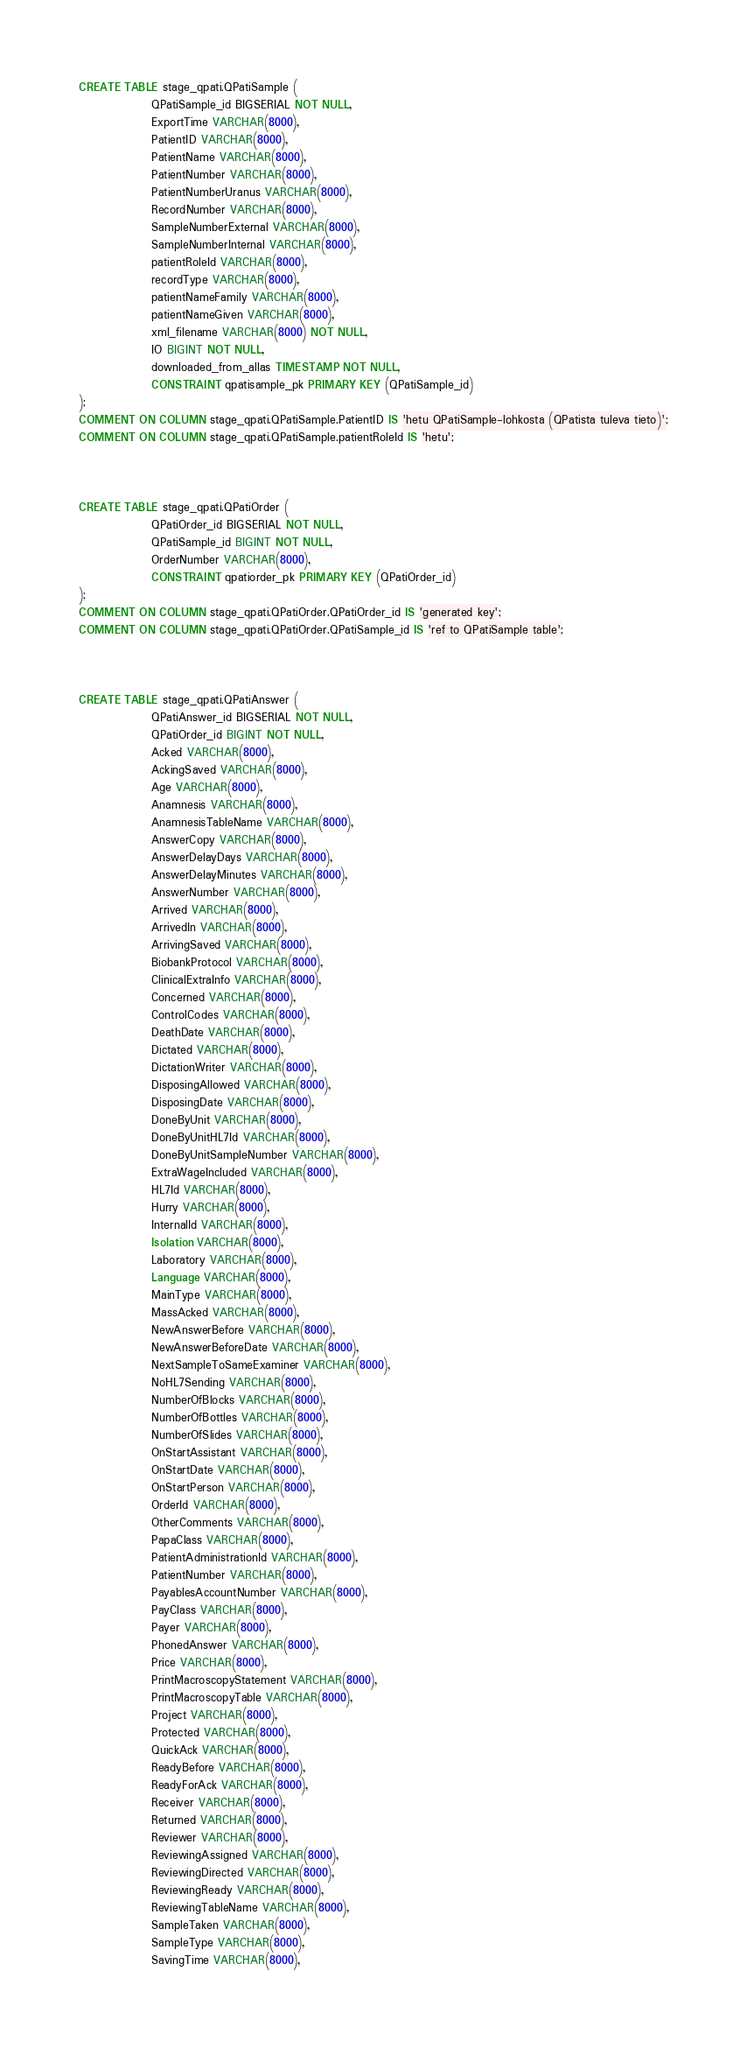Convert code to text. <code><loc_0><loc_0><loc_500><loc_500><_SQL_>
CREATE TABLE stage_qpati.QPatiSample (
                QPatiSample_id BIGSERIAL NOT NULL,
                ExportTime VARCHAR(8000),
                PatientID VARCHAR(8000),
                PatientName VARCHAR(8000),
                PatientNumber VARCHAR(8000),
                PatientNumberUranus VARCHAR(8000),
                RecordNumber VARCHAR(8000),
                SampleNumberExternal VARCHAR(8000),
                SampleNumberInternal VARCHAR(8000),
                patientRoleId VARCHAR(8000),
                recordType VARCHAR(8000),
                patientNameFamily VARCHAR(8000),
                patientNameGiven VARCHAR(8000),
                xml_filename VARCHAR(8000) NOT NULL,
                IO BIGINT NOT NULL,
                downloaded_from_allas TIMESTAMP NOT NULL,
                CONSTRAINT qpatisample_pk PRIMARY KEY (QPatiSample_id)
);
COMMENT ON COLUMN stage_qpati.QPatiSample.PatientID IS 'hetu QPatiSample-lohkosta (QPatista tuleva tieto)';
COMMENT ON COLUMN stage_qpati.QPatiSample.patientRoleId IS 'hetu';



CREATE TABLE stage_qpati.QPatiOrder (
                QPatiOrder_id BIGSERIAL NOT NULL,
                QPatiSample_id BIGINT NOT NULL,
                OrderNumber VARCHAR(8000),
                CONSTRAINT qpatiorder_pk PRIMARY KEY (QPatiOrder_id)
);
COMMENT ON COLUMN stage_qpati.QPatiOrder.QPatiOrder_id IS 'generated key';
COMMENT ON COLUMN stage_qpati.QPatiOrder.QPatiSample_id IS 'ref to QPatiSample table';



CREATE TABLE stage_qpati.QPatiAnswer (
                QPatiAnswer_id BIGSERIAL NOT NULL,
                QPatiOrder_id BIGINT NOT NULL,
                Acked VARCHAR(8000),
                AckingSaved VARCHAR(8000),
                Age VARCHAR(8000),
                Anamnesis VARCHAR(8000),
                AnamnesisTableName VARCHAR(8000),
                AnswerCopy VARCHAR(8000),
                AnswerDelayDays VARCHAR(8000),
                AnswerDelayMinutes VARCHAR(8000),
                AnswerNumber VARCHAR(8000),
                Arrived VARCHAR(8000),
                ArrivedIn VARCHAR(8000),
                ArrivingSaved VARCHAR(8000),
                BiobankProtocol VARCHAR(8000),
                ClinicalExtraInfo VARCHAR(8000),
                Concerned VARCHAR(8000),
                ControlCodes VARCHAR(8000),
                DeathDate VARCHAR(8000),
                Dictated VARCHAR(8000),
                DictationWriter VARCHAR(8000),
                DisposingAllowed VARCHAR(8000),
                DisposingDate VARCHAR(8000),
                DoneByUnit VARCHAR(8000),
                DoneByUnitHL7Id VARCHAR(8000),
                DoneByUnitSampleNumber VARCHAR(8000),
                ExtraWageIncluded VARCHAR(8000),
                HL7Id VARCHAR(8000),
                Hurry VARCHAR(8000),
                InternalId VARCHAR(8000),
                Isolation VARCHAR(8000),
                Laboratory VARCHAR(8000),
                Language VARCHAR(8000),
                MainType VARCHAR(8000),
                MassAcked VARCHAR(8000),
                NewAnswerBefore VARCHAR(8000),
                NewAnswerBeforeDate VARCHAR(8000),
                NextSampleToSameExaminer VARCHAR(8000),
                NoHL7Sending VARCHAR(8000),
                NumberOfBlocks VARCHAR(8000),
                NumberOfBottles VARCHAR(8000),
                NumberOfSlides VARCHAR(8000),
                OnStartAssistant VARCHAR(8000),
                OnStartDate VARCHAR(8000),
                OnStartPerson VARCHAR(8000),
                OrderId VARCHAR(8000),
                OtherComments VARCHAR(8000),
                PapaClass VARCHAR(8000),
                PatientAdministrationId VARCHAR(8000),
                PatientNumber VARCHAR(8000),
                PayablesAccountNumber VARCHAR(8000),
                PayClass VARCHAR(8000),
                Payer VARCHAR(8000),
                PhonedAnswer VARCHAR(8000),
                Price VARCHAR(8000),
                PrintMacroscopyStatement VARCHAR(8000),
                PrintMacroscopyTable VARCHAR(8000),
                Project VARCHAR(8000),
                Protected VARCHAR(8000),
                QuickAck VARCHAR(8000),
                ReadyBefore VARCHAR(8000),
                ReadyForAck VARCHAR(8000),
                Receiver VARCHAR(8000),
                Returned VARCHAR(8000),
                Reviewer VARCHAR(8000),
                ReviewingAssigned VARCHAR(8000),
                ReviewingDirected VARCHAR(8000),
                ReviewingReady VARCHAR(8000),
                ReviewingTableName VARCHAR(8000),
                SampleTaken VARCHAR(8000),
                SampleType VARCHAR(8000),
                SavingTime VARCHAR(8000),</code> 